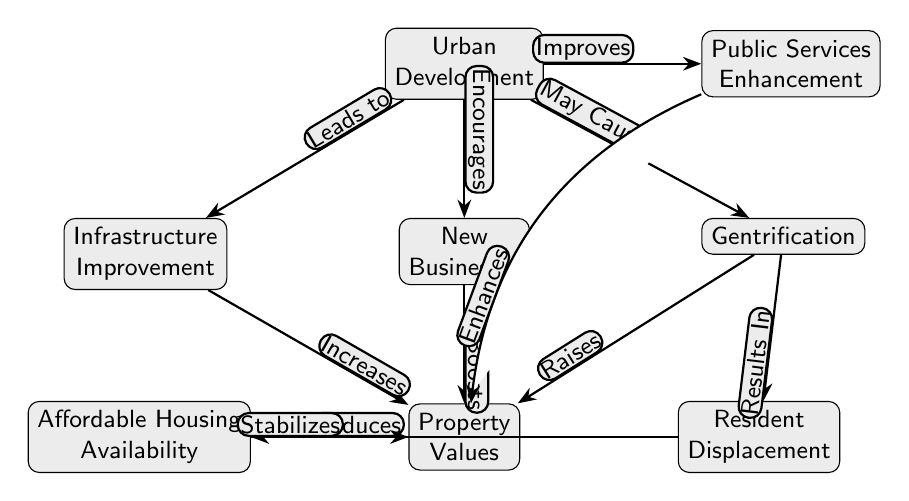What is the central node of the diagram? The central node is "Urban Development", which serves as a hub linking to other elements in the diagram.
Answer: Urban Development How many nodes are present in the diagram? By counting all the distinct entities in the diagram, we identify a total of 9 nodes.
Answer: 9 What relationship connects "Infrastructure Improvement" to "Property Values"? The connection is indicated as "Increases", showing that improvements in infrastructure have a positive effect on property values.
Answer: Increases What does "Gentrification" result in, according to the diagram? The relationship shows that "Gentrification" leads to "Resident Displacement", indicating that as areas become gentrified, residents may be forced to move.
Answer: Resident Displacement What enhances "Property Values" in the diagram? The diagram identifies multiple factors that enhance "Property Values", including "Infrastructure Improvement", "New Businesses", "Gentrification", and "Public Services Enhancement".
Answer: Multiple factors How does "Resident Displacement" affect "Affordable Housing Availability"? It shows a negative effect: "Displacement" reduces "Affordable Housing Availability", indicating that when residents are displaced, the availability of affordable housing decreases.
Answer: Reduces What is the connection between "New Businesses" and "Property Values"? The connection is labeled as "Boosts", which indicates that the arrival of new businesses has a favorable impact on property values.
Answer: Boosts If "Public Services" are improved, what is the expected effect on "Property Values"? "Public Services Enhancement" is linked to "Property Values" with "Enhances", indicating that improved services lead to higher property values.
Answer: Enhances What consequence does "Gentrification" have on "Affordable Housing Availability"? The flow illustrates that "Gentrification" results in resident displacement, which subsequently reduces affordable housing availability.
Answer: Reduces 